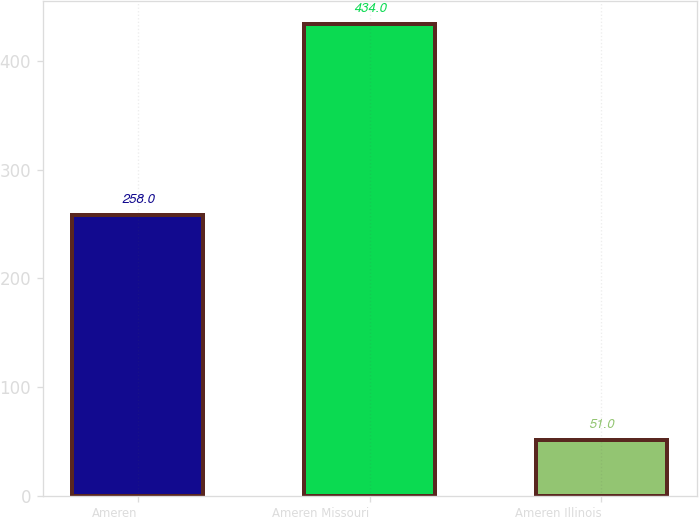<chart> <loc_0><loc_0><loc_500><loc_500><bar_chart><fcel>Ameren<fcel>Ameren Missouri<fcel>Ameren Illinois<nl><fcel>258<fcel>434<fcel>51<nl></chart> 